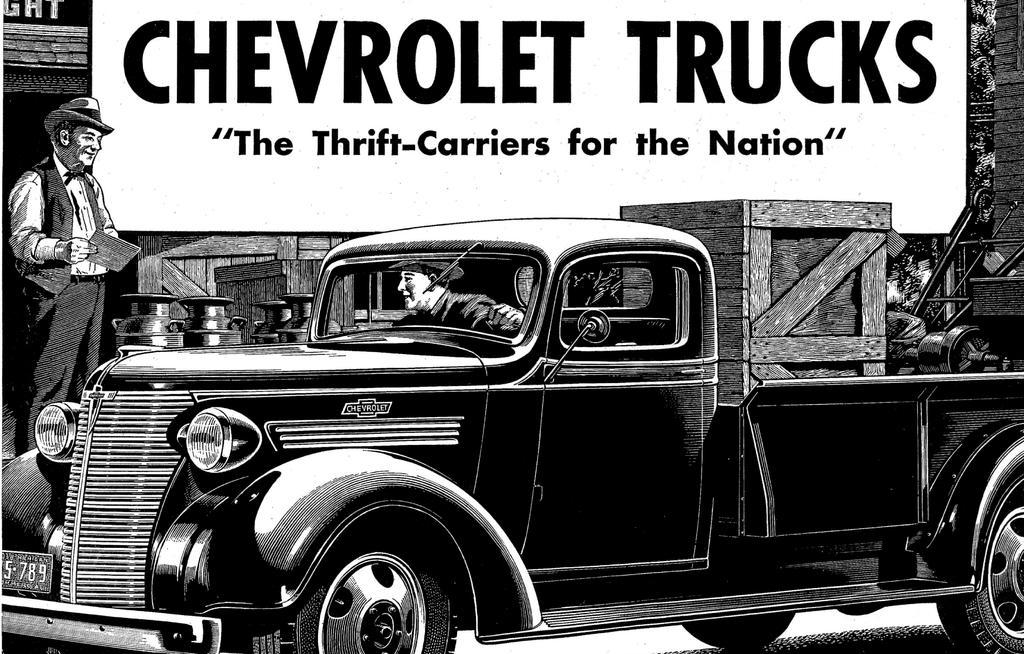Describe this image in one or two sentences. In this image there is a black and white sketch, in the sketch there is a person driving a car, beside the car there is a person standing, behind the person there is a display board, in front of the display board there are wooden boxes, beside the wooden boxes there is a metal trolley. 